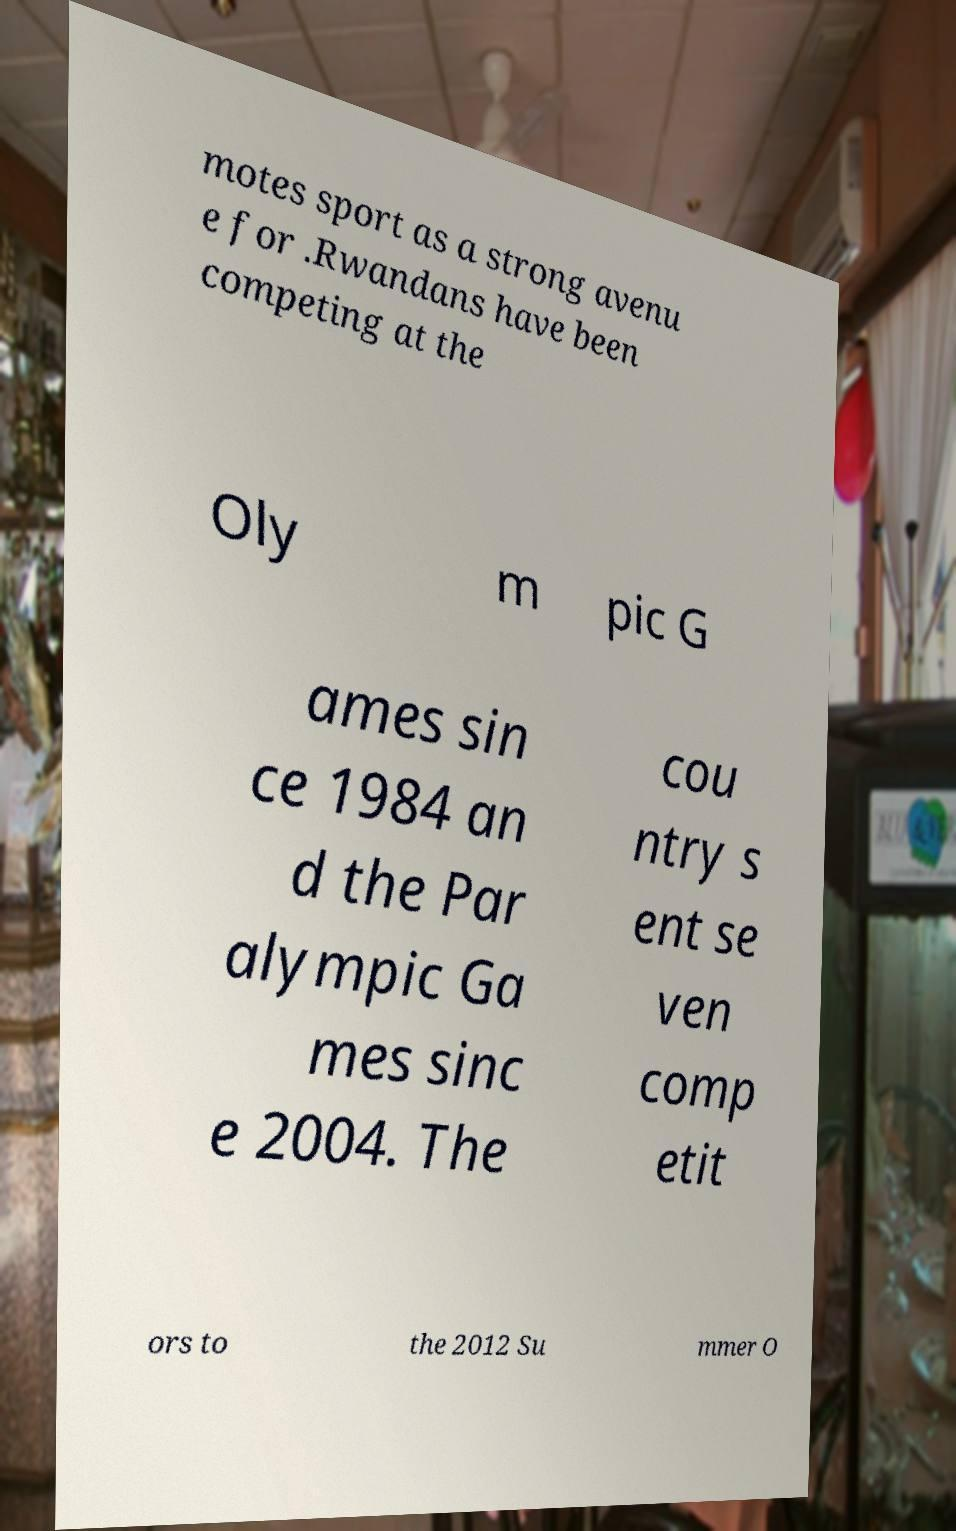Please read and relay the text visible in this image. What does it say? motes sport as a strong avenu e for .Rwandans have been competing at the Oly m pic G ames sin ce 1984 an d the Par alympic Ga mes sinc e 2004. The cou ntry s ent se ven comp etit ors to the 2012 Su mmer O 